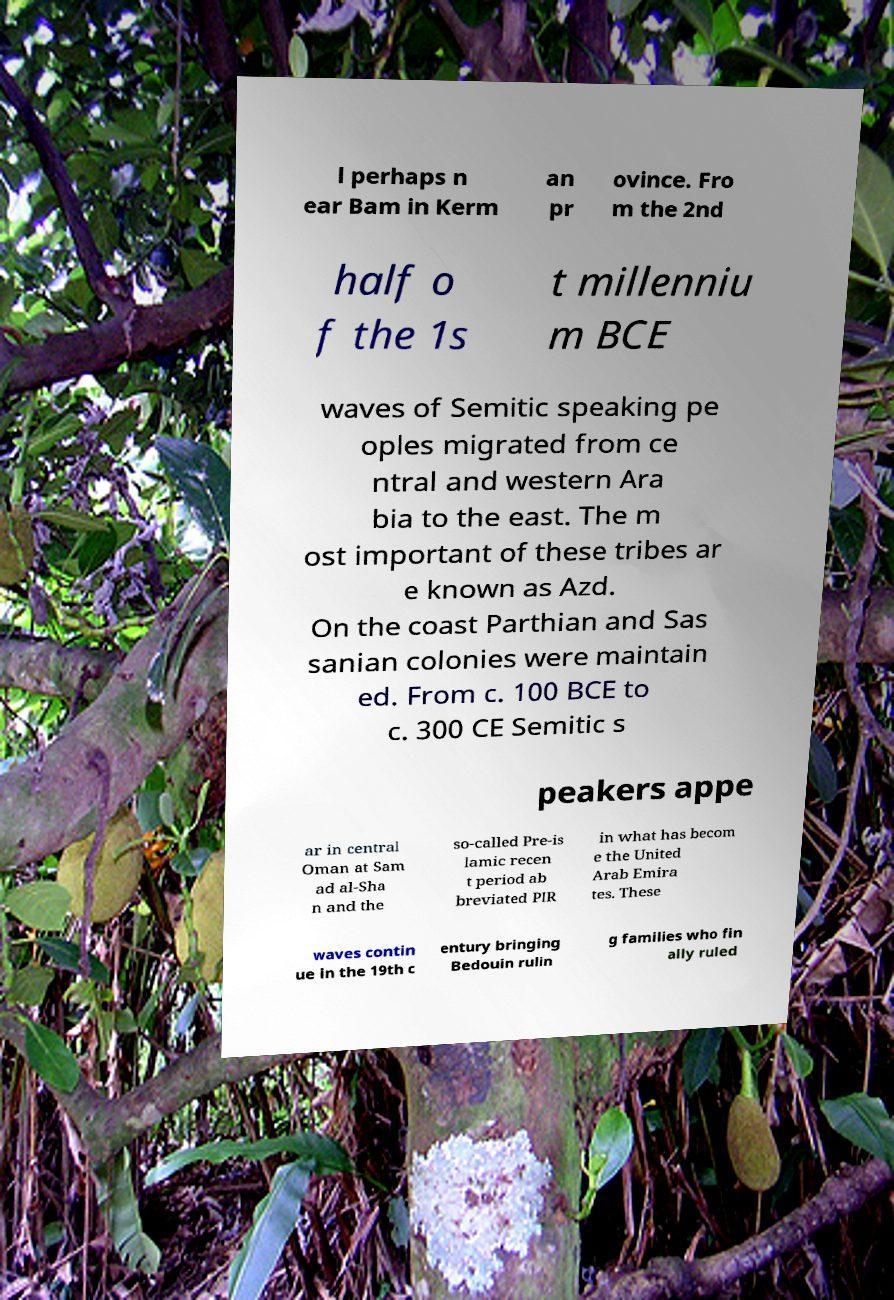Could you assist in decoding the text presented in this image and type it out clearly? l perhaps n ear Bam in Kerm an pr ovince. Fro m the 2nd half o f the 1s t millenniu m BCE waves of Semitic speaking pe oples migrated from ce ntral and western Ara bia to the east. The m ost important of these tribes ar e known as Azd. On the coast Parthian and Sas sanian colonies were maintain ed. From c. 100 BCE to c. 300 CE Semitic s peakers appe ar in central Oman at Sam ad al-Sha n and the so-called Pre-is lamic recen t period ab breviated PIR in what has becom e the United Arab Emira tes. These waves contin ue in the 19th c entury bringing Bedouin rulin g families who fin ally ruled 